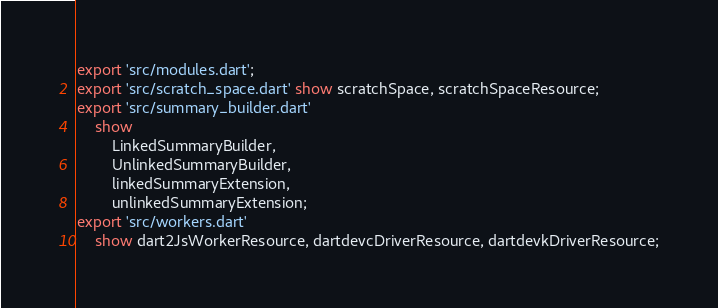<code> <loc_0><loc_0><loc_500><loc_500><_Dart_>export 'src/modules.dart';
export 'src/scratch_space.dart' show scratchSpace, scratchSpaceResource;
export 'src/summary_builder.dart'
    show
        LinkedSummaryBuilder,
        UnlinkedSummaryBuilder,
        linkedSummaryExtension,
        unlinkedSummaryExtension;
export 'src/workers.dart'
    show dart2JsWorkerResource, dartdevcDriverResource, dartdevkDriverResource;
</code> 